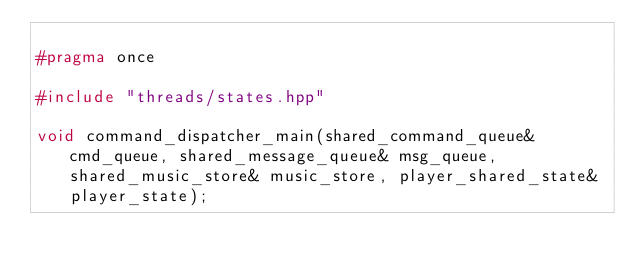Convert code to text. <code><loc_0><loc_0><loc_500><loc_500><_C++_>
#pragma once

#include "threads/states.hpp"

void command_dispatcher_main(shared_command_queue& cmd_queue, shared_message_queue& msg_queue, shared_music_store& music_store, player_shared_state& player_state);

</code> 